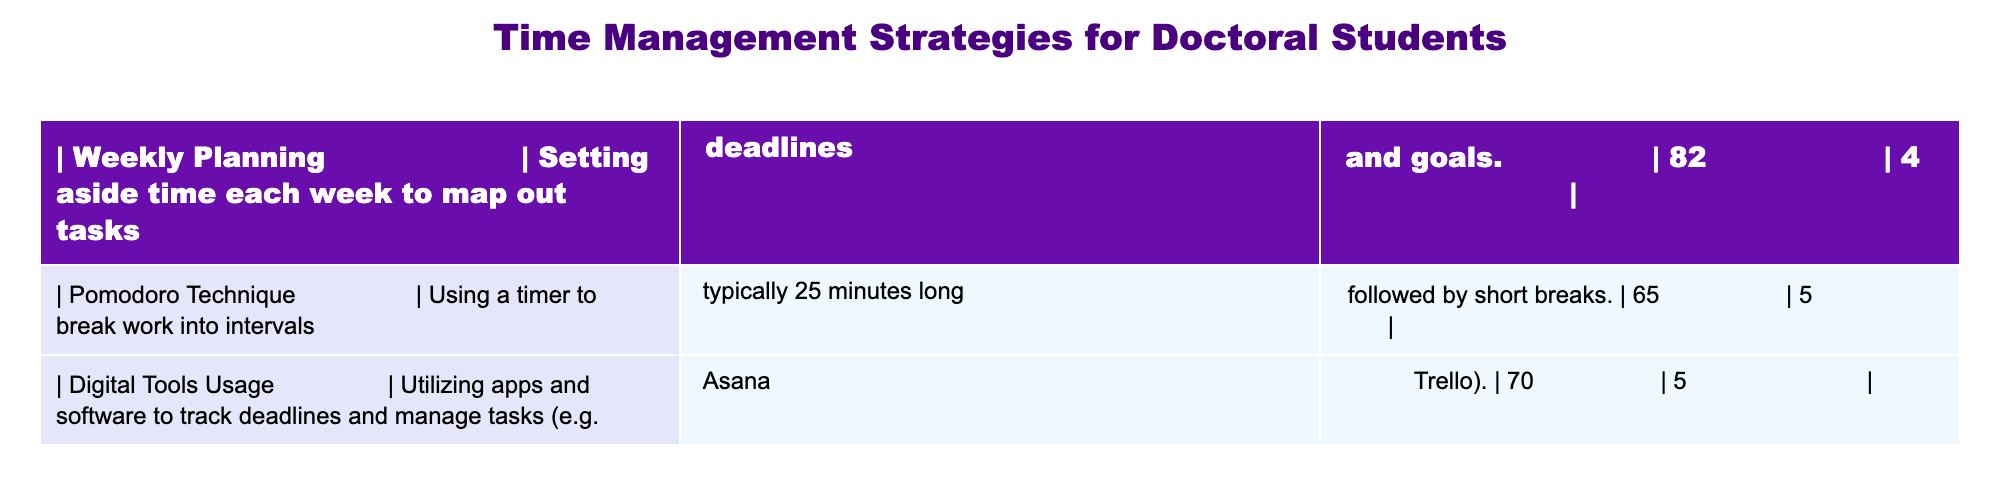What is the percentage of doctoral students using the Weekly Planning strategy? The table shows that 82 out of 100 students, which is indicated as a percentage. Thus, the percentage is 82%.
Answer: 82% Which time management strategy has the highest number of respondents? The data shows that the Weekly Planning strategy has 82 respondents, which is higher than the Pomodoro Technique (65) and Digital Tools Usage (70).
Answer: Weekly Planning Is the Pomodoro Technique used by more respondents than Digital Tools Usage? The Pomodoro Technique has 65 respondents while Digital Tools Usage has 70 respondents. Since 65 is less than 70, the statement is false.
Answer: No What is the difference in the number of respondents between Digital Tools Usage and Weekly Planning? Digital Tools Usage has 70 respondents and Weekly Planning has 82. The difference is 82 - 70, which equals 12.
Answer: 12 What is the average number of respondents for the three strategies? To find the average, sum all the respondents: 82 + 65 + 70 = 217. Then divide by 3 (the number of strategies): 217 / 3 = 72.33, rounding to two decimal places gives 72.33.
Answer: 72.33 If a student were to randomly select between the three strategies, what is the probability they would choose one of the top two strategies based on the number of respondents? The two strategies with the highest number of respondents are Weekly Planning (82) and Digital Tools Usage (70). Combined, they total 82 + 70 = 152. The probability is then calculated by dividing 152 (top strategies) by the total number of respondents (82 + 65 + 70 = 217). Thus, the probability is 152/217, which simplifies to approximately 0.699.
Answer: 0.699 Does the data suggest that a majority of students in the sample are utilizing digital tools? Among the 217 respondents, Digital Tools Usage has 70 respondents, which is approximately 32.2%. Since 32.2% is less than 50%, the majority is not utilizing digital tools. Therefore, the statement is false.
Answer: No What is the relationship between the reported strategies and their numbers of respondents? The table shows that as the complexity of a strategy increases (from Weekly Planning to Pomodoro Technique to Digital Tools Usage), there is a decreasing trend in the number of respondents, suggesting that simpler strategies are favored over more complex ones.
Answer: Decreasing trend in respondents 